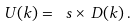Convert formula to latex. <formula><loc_0><loc_0><loc_500><loc_500>U ( k ) = \ s \times \, D ( k ) \, .</formula> 